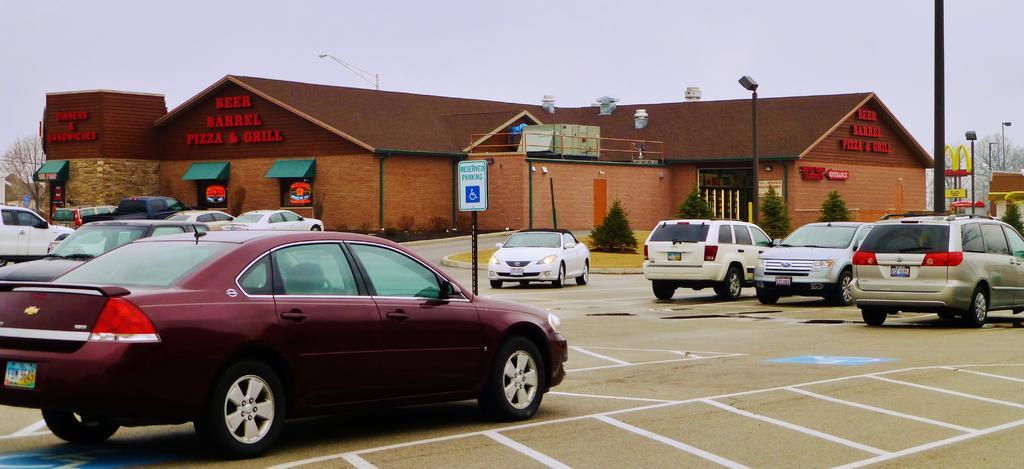Please provide a concise description of this image. In the picture we can see a road with some white color lines and some vehicles on it and we can see a pole with a board mentioned in it as reserved parking and behind it, we can see a restaurant which is brown in color and near to it, we can see some poles with lights and on the either sides of the restaurant we can see some trees and behind the restaurant building we can see the sky. 